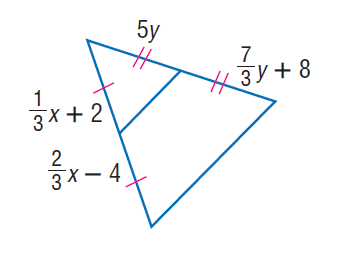Answer the mathemtical geometry problem and directly provide the correct option letter.
Question: Find x.
Choices: A: 16 B: 18 C: 24 D: 27 B 